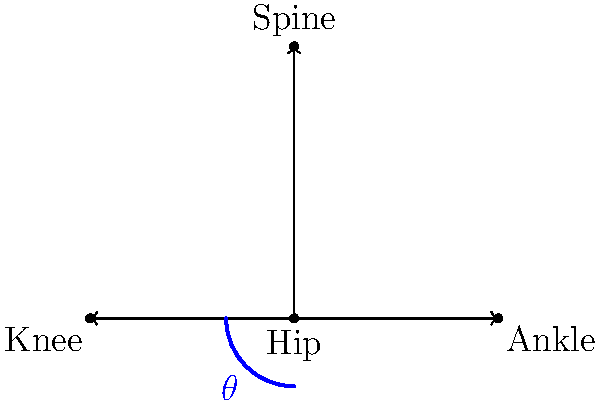In the traditional Hawaiian hula dance movement "uehe" (foot lift), what is the approximate angle $\theta$ formed at the hip joint when the dancer lifts their foot off the ground, and which primary muscle group is activated to achieve this motion? To answer this question, let's break down the biomechanics of the "uehe" movement:

1. The "uehe" movement involves lifting the foot off the ground while maintaining an upright posture.

2. This motion primarily engages the hip flexor muscles, particularly the iliopsoas group.

3. The angle $\theta$ formed at the hip joint during this movement can be estimated as follows:
   a. In a neutral standing position, the angle between the spine and the thigh is approximately 180°.
   b. When performing the "uehe", the thigh is raised, reducing this angle.
   c. For a typical foot lift in hula, the thigh is raised about 45° from the vertical.

4. To calculate the hip angle $\theta$:
   $$\theta = 180° - 45° = 135°$$

5. The primary muscle group activated during this movement is the hip flexors, which include:
   - Iliopsoas (combination of psoas major and iliacus)
   - Rectus femoris
   - Sartorius

6. These muscles contract to lift the thigh, creating the characteristic "uehe" movement in hula dance.
Answer: $\theta \approx 135°$; Hip flexors (primarily iliopsoas) 